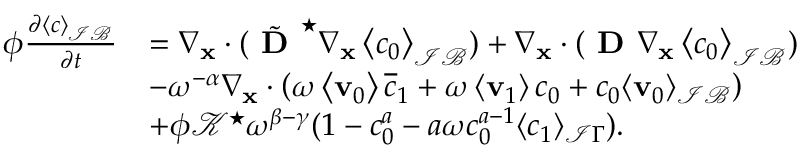Convert formula to latex. <formula><loc_0><loc_0><loc_500><loc_500>\begin{array} { r l } { \phi \frac { \partial \left \langle c \right \rangle _ { \mathcal { I B } } } { \partial t } } & { = \nabla _ { x } \cdot ( \tilde { D } ^ { ^ { * } } \nabla _ { \mathbf x } \left \langle c _ { 0 } \right \rangle _ { \mathcal { I B } } ) + \nabla _ { \mathbf x } \cdot ( D \nabla _ { \mathbf x } \left \langle c _ { 0 } \right \rangle _ { \mathcal { I B } } ) } \\ & { - \omega ^ { - \alpha } \nabla _ { \mathbf x } \cdot \left ( \omega \left \langle \mathbf v _ { 0 } \right \rangle \overline { c } _ { 1 } + \omega \left \langle \mathbf v _ { 1 } \right \rangle c _ { 0 } + c _ { 0 } \langle \mathbf v _ { 0 } \rangle _ { \mathcal { I B } } \right ) } \\ & { + \phi \mathcal { K } ^ { ^ { * } } \omega ^ { \beta - \gamma } ( 1 - c _ { 0 } ^ { a } - a \omega c _ { 0 } ^ { a - 1 } \langle c _ { 1 } \rangle _ { \mathcal { I } \Gamma } ) . } \end{array}</formula> 